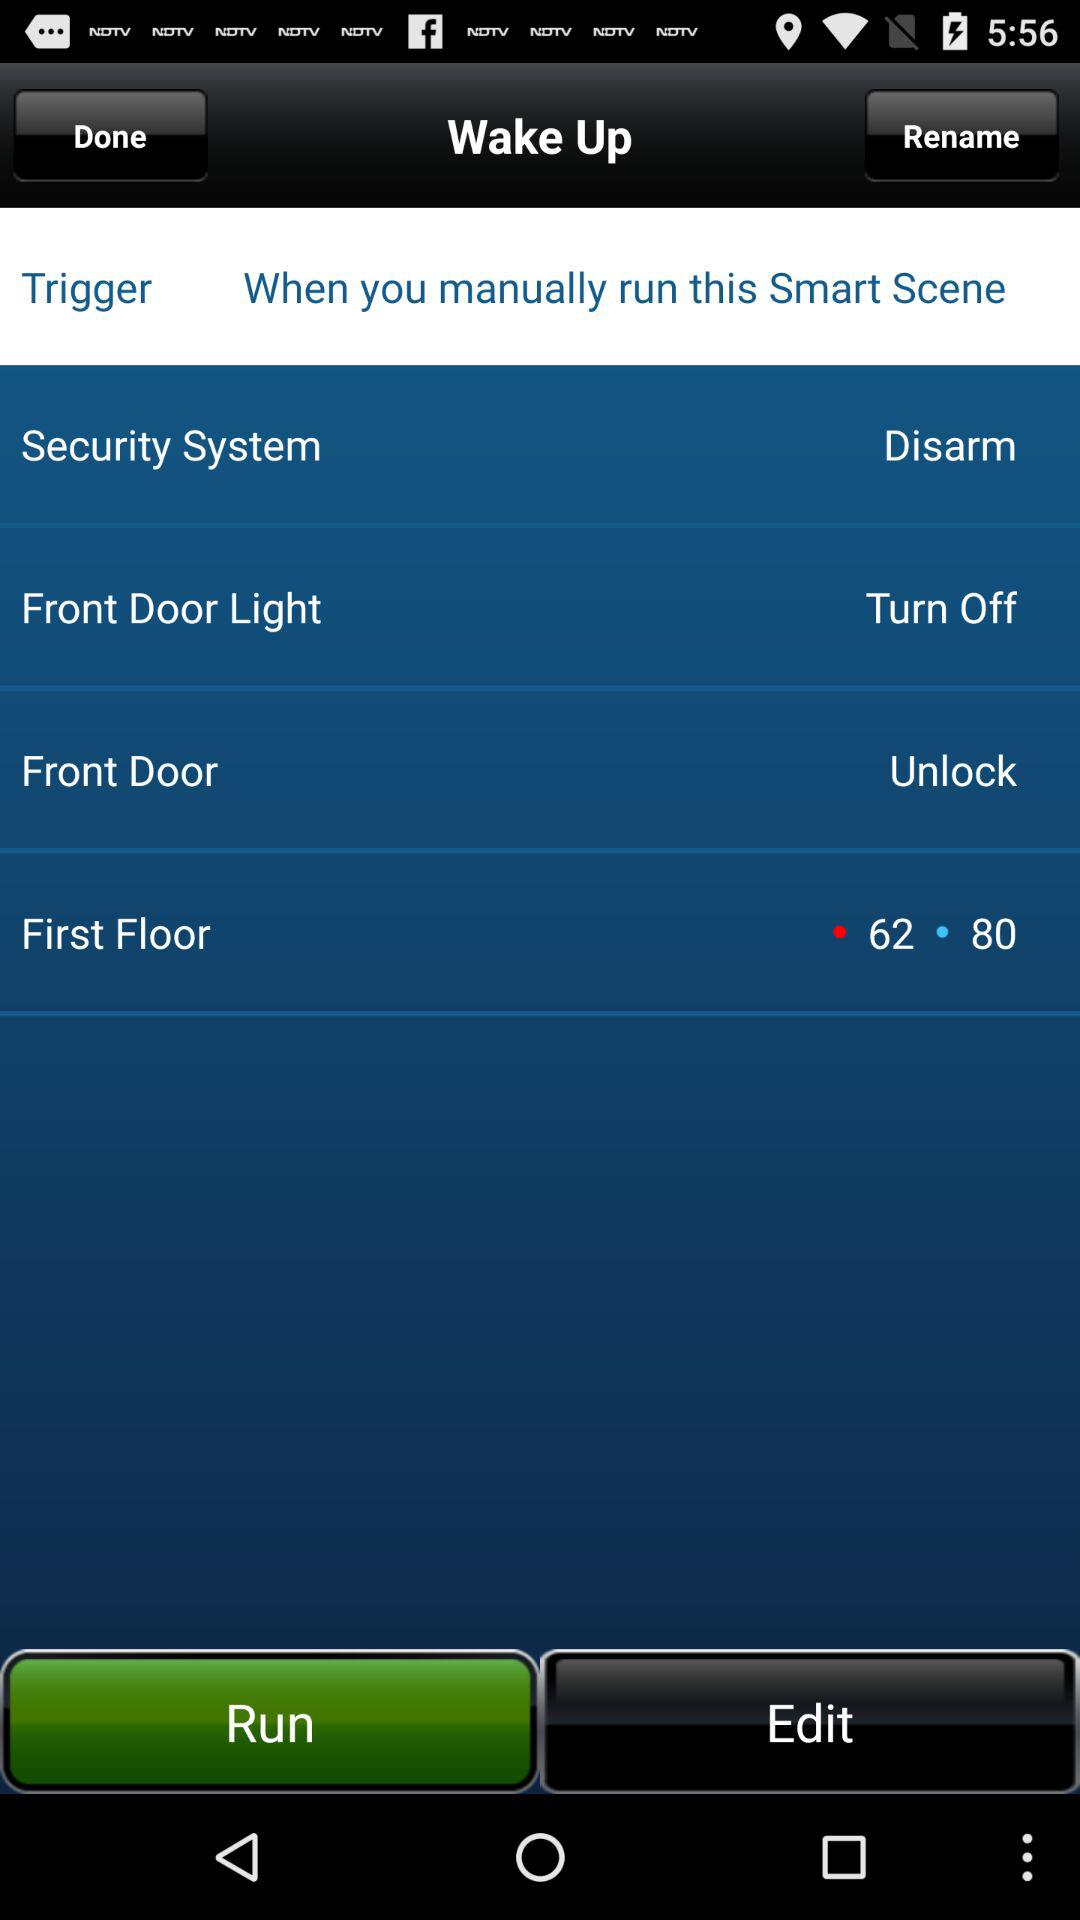For which option the triggered setting is "62 or 80"? "62 or 80" is the triggered setting for "First Floor". 